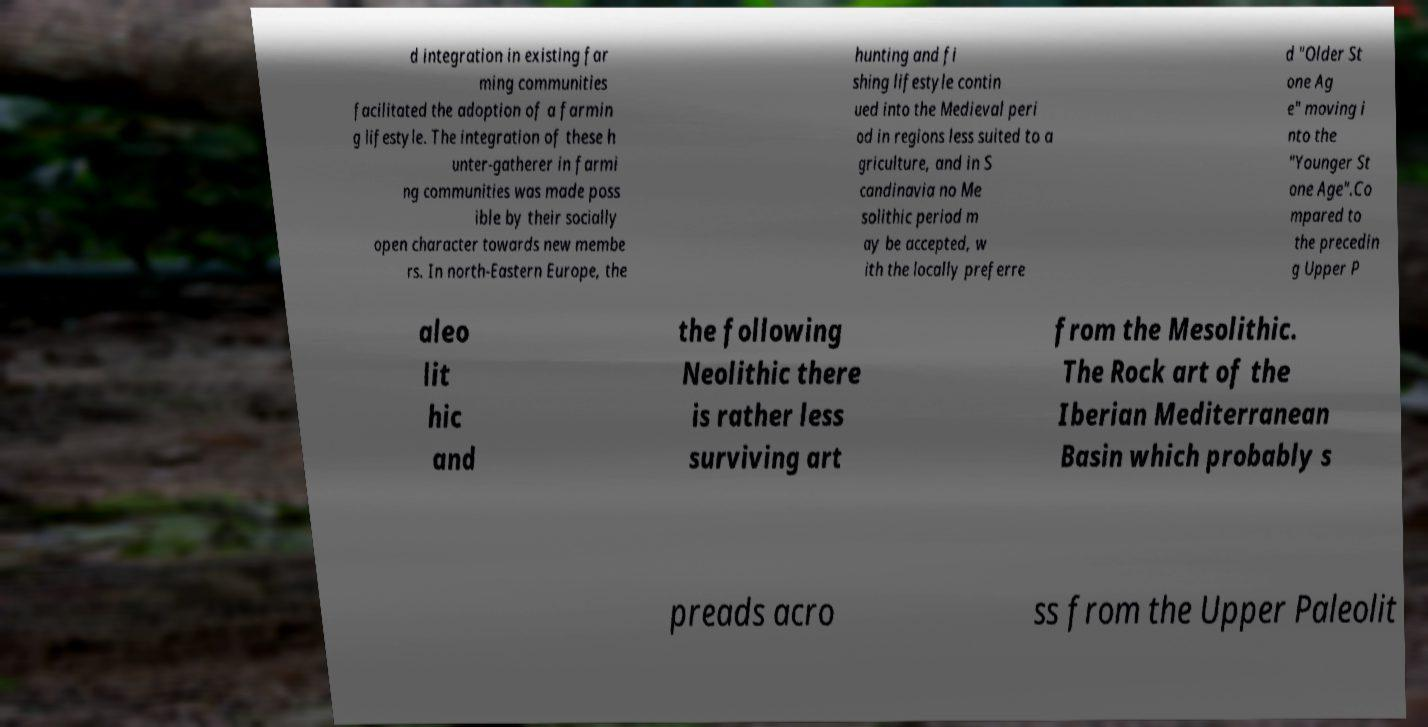What messages or text are displayed in this image? I need them in a readable, typed format. d integration in existing far ming communities facilitated the adoption of a farmin g lifestyle. The integration of these h unter-gatherer in farmi ng communities was made poss ible by their socially open character towards new membe rs. In north-Eastern Europe, the hunting and fi shing lifestyle contin ued into the Medieval peri od in regions less suited to a griculture, and in S candinavia no Me solithic period m ay be accepted, w ith the locally preferre d "Older St one Ag e" moving i nto the "Younger St one Age".Co mpared to the precedin g Upper P aleo lit hic and the following Neolithic there is rather less surviving art from the Mesolithic. The Rock art of the Iberian Mediterranean Basin which probably s preads acro ss from the Upper Paleolit 